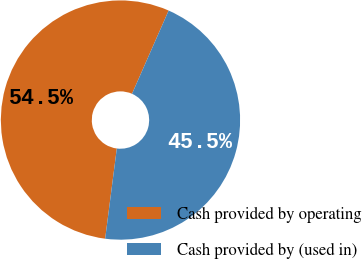Convert chart. <chart><loc_0><loc_0><loc_500><loc_500><pie_chart><fcel>Cash provided by operating<fcel>Cash provided by (used in)<nl><fcel>54.55%<fcel>45.45%<nl></chart> 